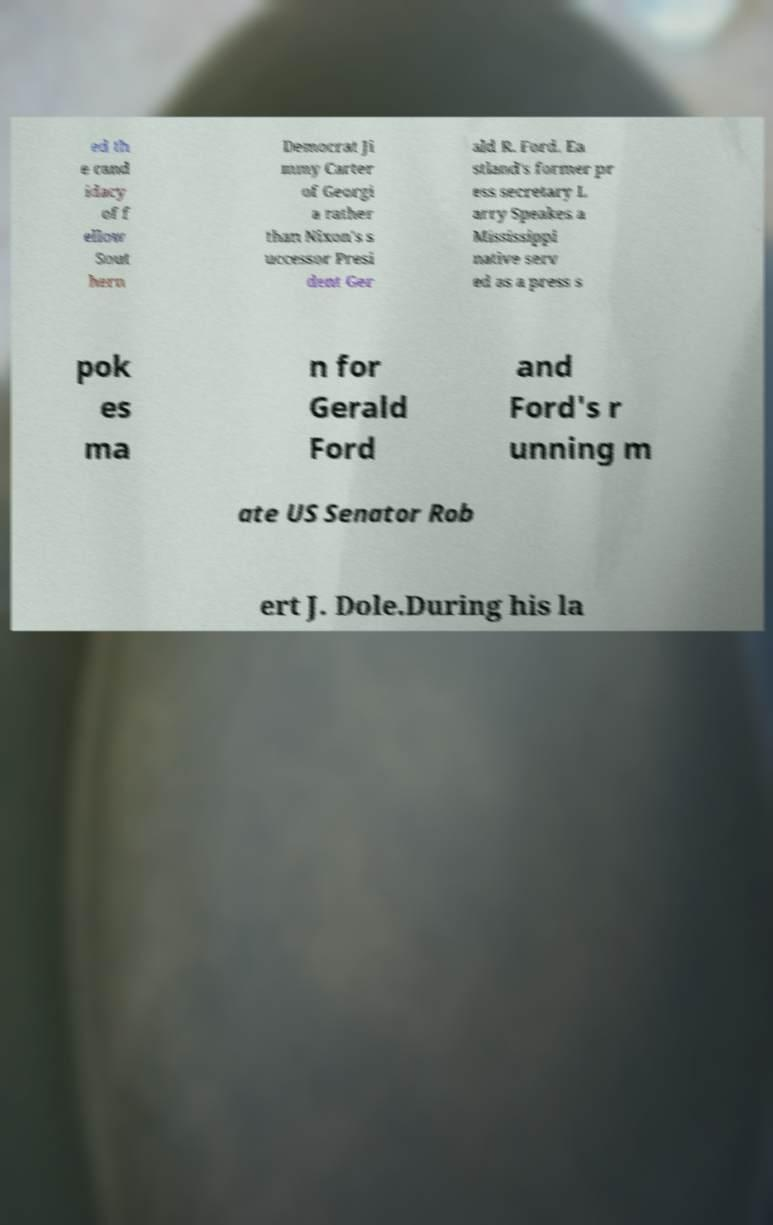For documentation purposes, I need the text within this image transcribed. Could you provide that? ed th e cand idacy of f ellow Sout hern Democrat Ji mmy Carter of Georgi a rather than Nixon's s uccessor Presi dent Ger ald R. Ford. Ea stland's former pr ess secretary L arry Speakes a Mississippi native serv ed as a press s pok es ma n for Gerald Ford and Ford's r unning m ate US Senator Rob ert J. Dole.During his la 